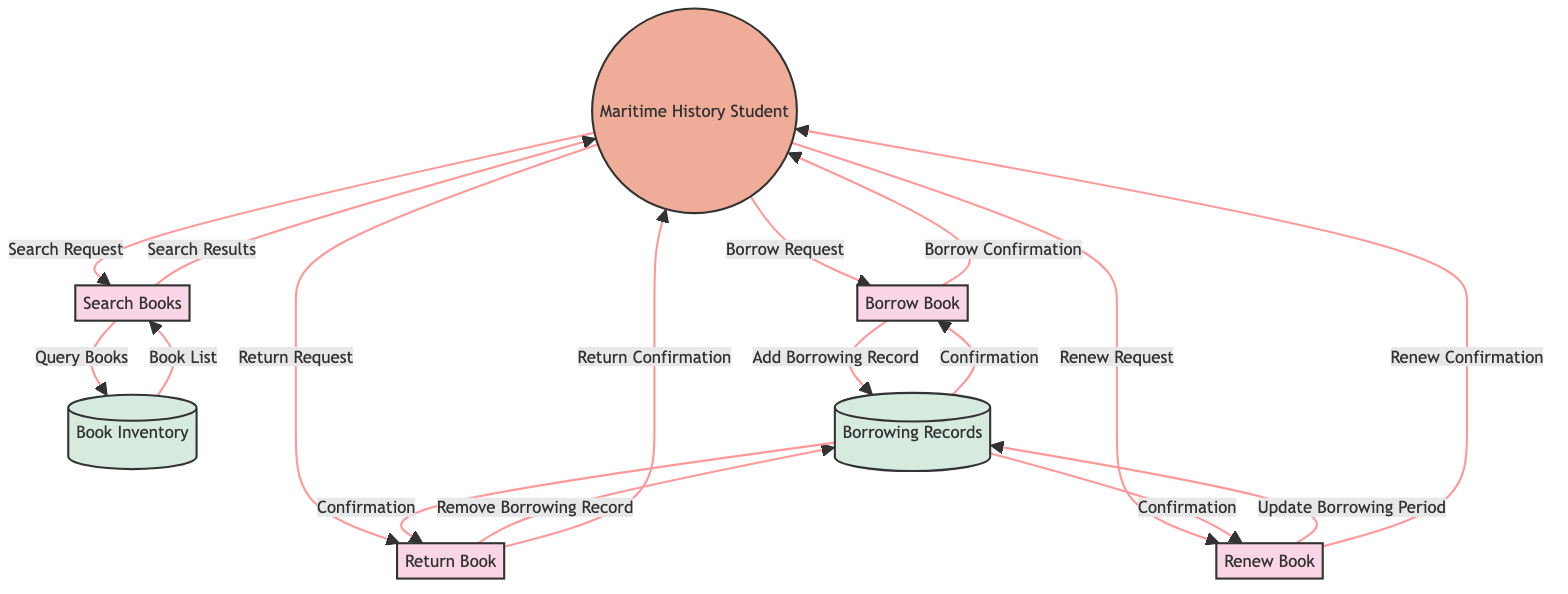What is the first process in the diagram? The first process in the diagram is labeled as "Search Books." It is the initial step where the Maritime History Student interacts with the system.
Answer: Search Books How many processes are there in total? By counting the labeled processes in the diagram, there are four distinct processes: Search Books, Borrow Book, Return Book, and Renew Book.
Answer: Four Which entity interacts with the "Borrow Book" process? The entity that interacts with the "Borrow Book" process is the "Maritime History Student." This can be seen in the arrow pointing from the student to the borrowing process.
Answer: Maritime History Student What is the data flow from "Return Book" to "Borrowing Records"? The data flow is described as "Remove Borrowing Record." This indicates that the returned book's record is removed from the database of Borrowing Records during the return process.
Answer: Remove Borrowing Record What confirmation does the "Return Book" process send back to the student? The "Return Book" process sends back a "Return Confirmation" to the Maritime History Student, signaling the completion of the return process.
Answer: Return Confirmation What are the two datastores shown in the diagram? The two datastores are "Book Inventory" and "Borrowing Records." These databases hold the information required for the processes outlined in the diagram.
Answer: Book Inventory, Borrowing Records What request does a student make to renew a book? The student makes a "Renew Request" to initiate the process of extending the borrowing period of a book.
Answer: Renew Request How does "Borrow Book" confirm a successful borrowing? It confirms a successful borrowing by sending a "Borrow Confirmation" back to the Maritime History Student after the borrowing record is added.
Answer: Borrow Confirmation Which process follows "Search Books" in terms of interaction? The process that follows "Search Books" in terms of interaction is "Borrow Book," as the student can proceed to borrow a book after searching for it.
Answer: Borrow Book 